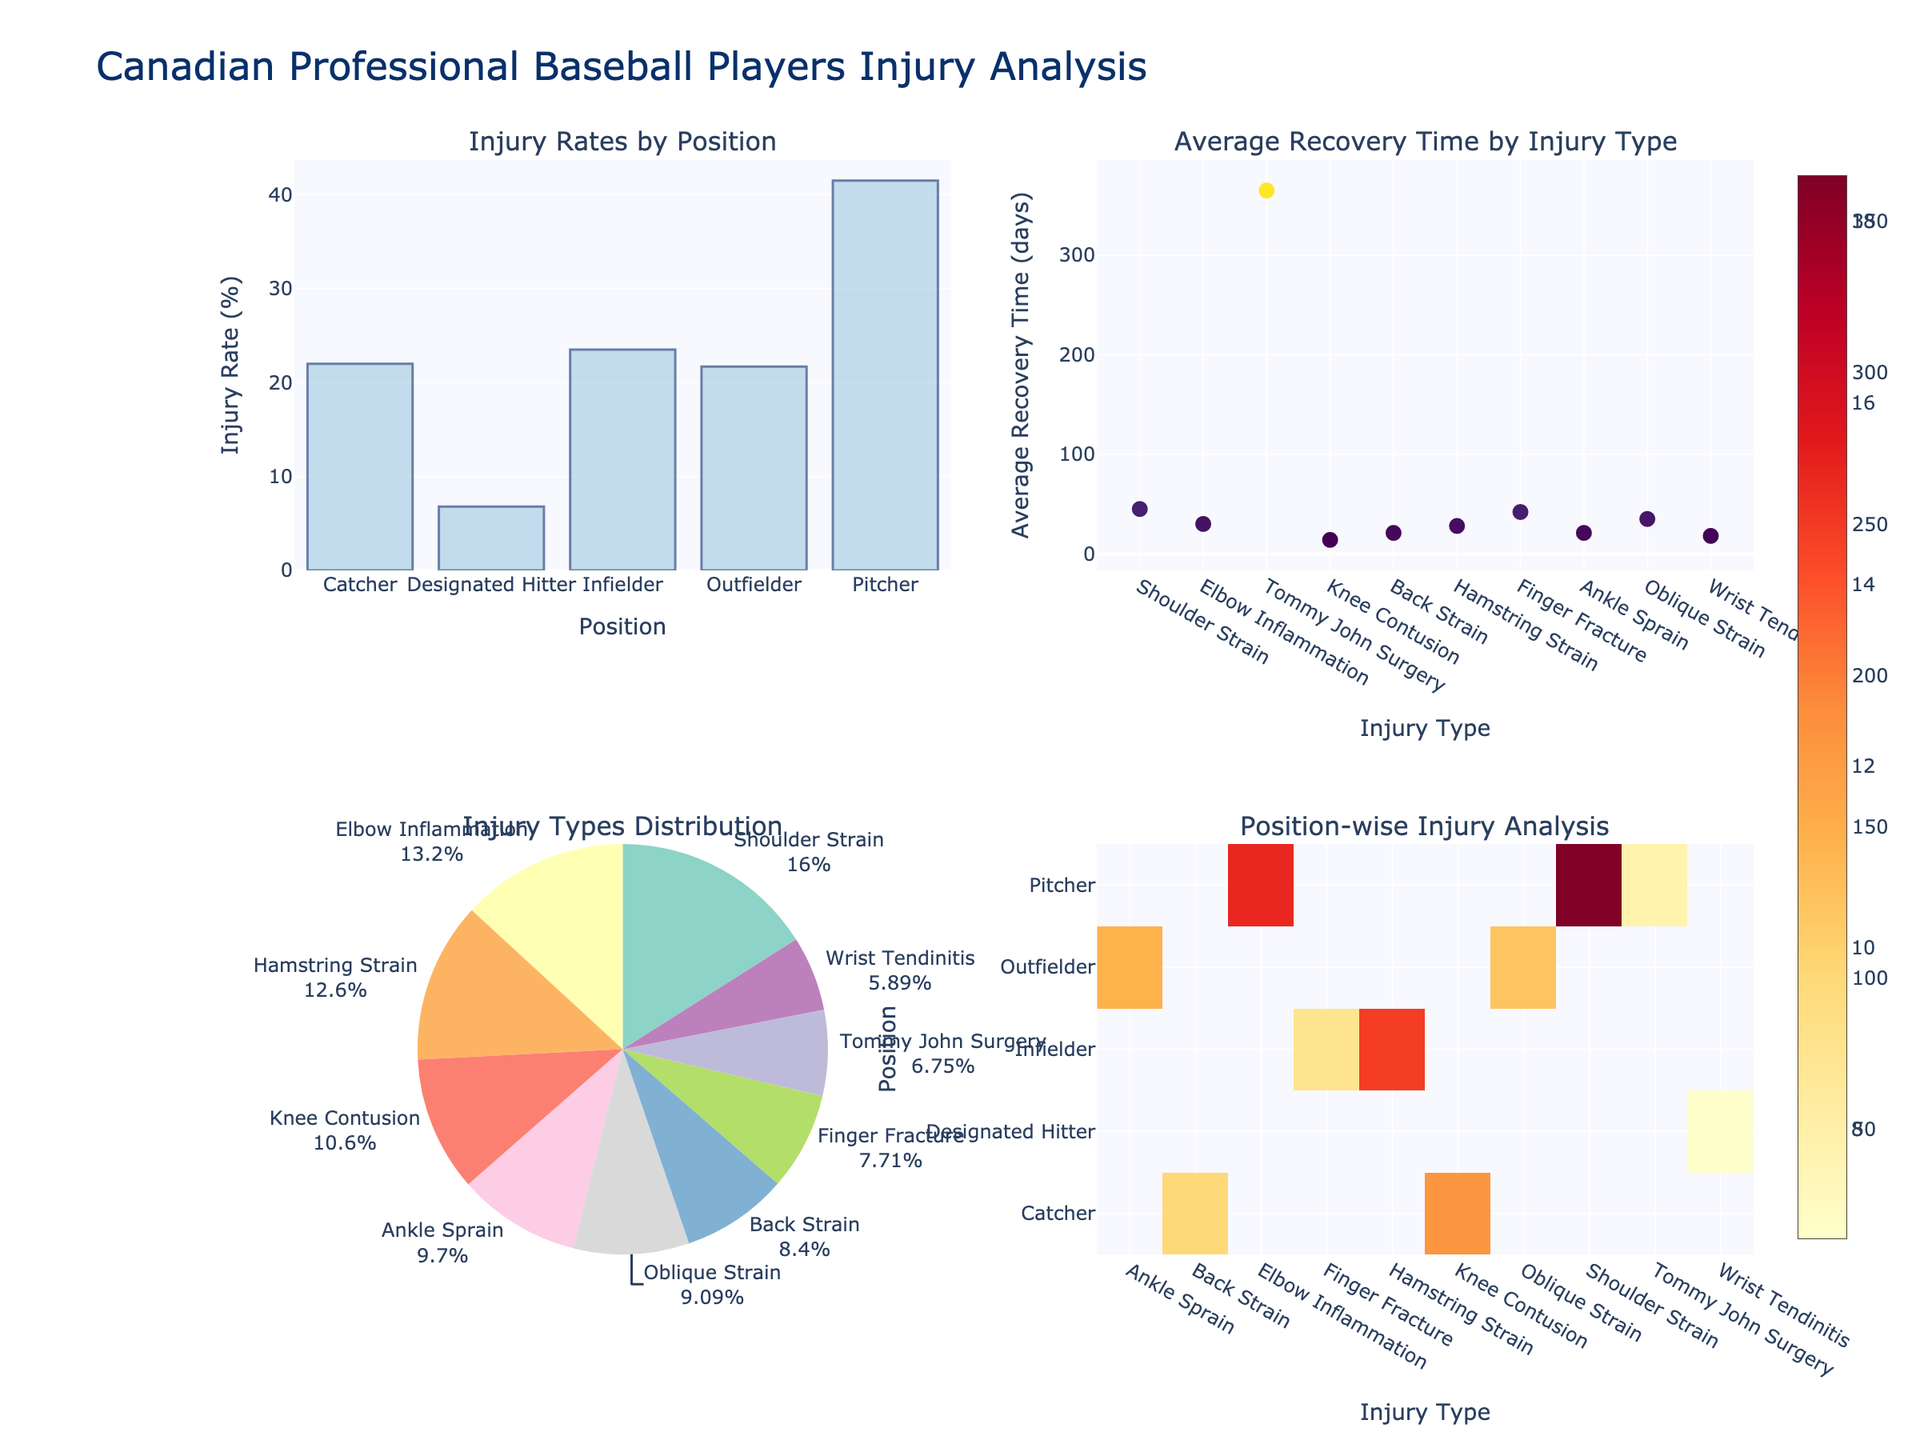What is the title of the figure? The title is displayed prominently at the top of the figure. It reads "Canadian Professional Baseball Players Injury Analysis" which summarizes the topic of the figure.
Answer: Canadian Professional Baseball Players Injury Analysis Which position has the highest total injury rate according to the bar chart? The bar chart in the top-left subplot shows the sum of injury rates for each position. The Pitcher position has the highest bar, indicating the highest total injury rate.
Answer: Pitcher Which injury type has the longest average recovery time based on the scatter plot? The scatter plot in the top-right subplot plots various injury types against their average recovery time. The data point farthest along the y-axis represents "Tommy John Surgery" with an average recovery time of 365 days.
Answer: Tommy John Surgery What percentage of injuries is due to Shoulder Strain according to the pie chart? The pie chart in the bottom-left subplot shows the distribution of injury types. Hovering or inspecting the segment labeled "Shoulder Strain" shows its percentage.
Answer: 18.5% How does the injury rate of Hamstring Strain for Infielders compare to Wrist Tendinitis for Designated Hitters in the heatmap? The heatmap in the bottom-right subplot displays injury rates by position and injury type. "Hamstring Strain" for Infielders is indicated at 14.6% while "Wrist Tendinitis" for Designated Hitters is at 6.8%.
Answer: Hamstring Strain is higher Which subplot specifically shows the relationship between injury type and average recovery time? The relationship between injury type and average recovery time is depicted in the scatter plot in the top-right subplot.
Answer: Scatter plot (top-right) Compare the recovery time for Knee Contusion and Back Strain for Catchers based on the scatter plot. Looking at the scatter plot, Knee Contusion shows approximately 14 days on average while Back Strain shows approximately 21 days on average.
Answer: Back Strain takes longer Identify two injury types for Outfielders and compare their injury rates as shown in the heatmap. In the heatmap, "Ankle Sprain" and "Oblique Strain" are the two types of injuries for Outfielders. Ankle Sprain has an injury rate of 11.2% and Oblique Strain has 10.5%.
Answer: Ankle Sprain is higher What is the injury rate for Elbow Inflammation among Pitchers shown in the data? Reading from the data associated with the figure, the injury rate for Elbow Inflammation among Pitchers is 15.2%.
Answer: 15.2% What does the heatmap indicate about the injury rate pattern among Catchers? The heatmap indicates Knee Contusion (12.3%) and Back Strain (9.7%) are common injuries among Catchers. Their injury rates are relatively high compared to other positions.
Answer: High for Knee Contusion and Back Strain 